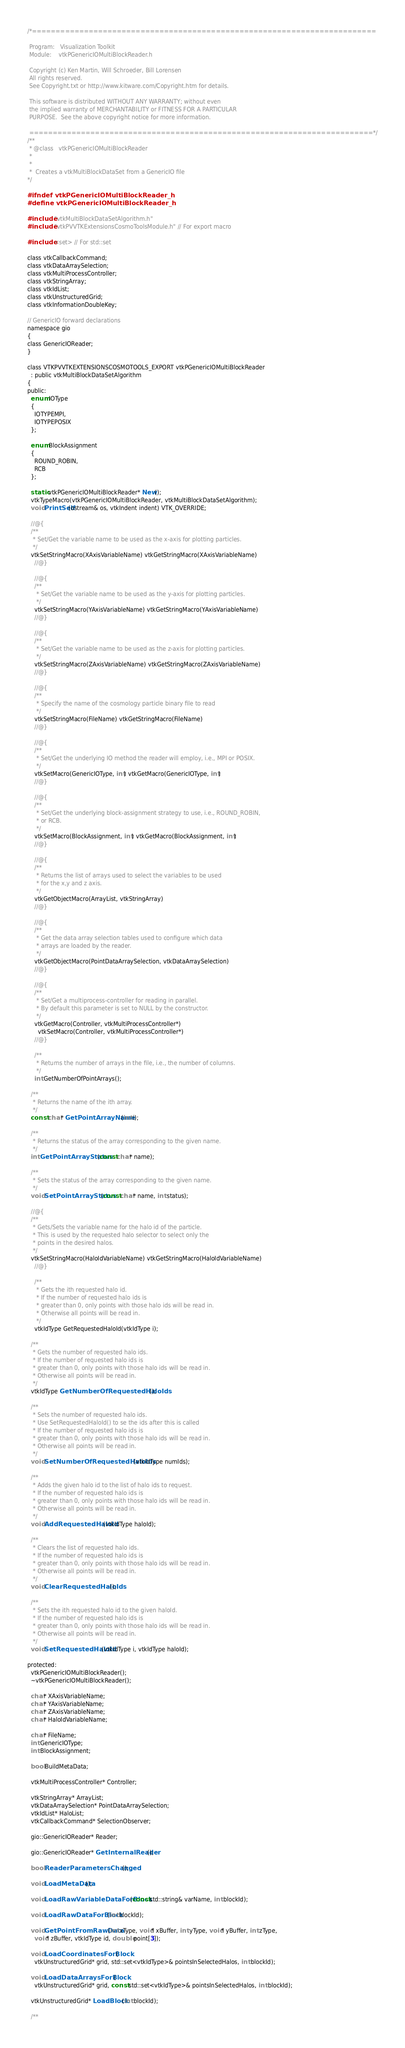Convert code to text. <code><loc_0><loc_0><loc_500><loc_500><_C_>/*=========================================================================

 Program:   Visualization Toolkit
 Module:    vtkPGenericIOMultiBlockReader.h

 Copyright (c) Ken Martin, Will Schroeder, Bill Lorensen
 All rights reserved.
 See Copyright.txt or http://www.kitware.com/Copyright.htm for details.

 This software is distributed WITHOUT ANY WARRANTY; without even
 the implied warranty of MERCHANTABILITY or FITNESS FOR A PARTICULAR
 PURPOSE.  See the above copyright notice for more information.

 =========================================================================*/
/**
 * @class   vtkPGenericIOMultiBlockReader
 *
 *
 *  Creates a vtkMultiBlockDataSet from a GenericIO file
*/

#ifndef vtkPGenericIOMultiBlockReader_h
#define vtkPGenericIOMultiBlockReader_h

#include "vtkMultiBlockDataSetAlgorithm.h"
#include "vtkPVVTKExtensionsCosmoToolsModule.h" // For export macro

#include <set> // For std::set

class vtkCallbackCommand;
class vtkDataArraySelection;
class vtkMultiProcessController;
class vtkStringArray;
class vtkIdList;
class vtkUnstructuredGrid;
class vtkInformationDoubleKey;

// GenericIO forward declarations
namespace gio
{
class GenericIOReader;
}

class VTKPVVTKEXTENSIONSCOSMOTOOLS_EXPORT vtkPGenericIOMultiBlockReader
  : public vtkMultiBlockDataSetAlgorithm
{
public:
  enum IOType
  {
    IOTYPEMPI,
    IOTYPEPOSIX
  };

  enum BlockAssignment
  {
    ROUND_ROBIN,
    RCB
  };

  static vtkPGenericIOMultiBlockReader* New();
  vtkTypeMacro(vtkPGenericIOMultiBlockReader, vtkMultiBlockDataSetAlgorithm);
  void PrintSelf(ostream& os, vtkIndent indent) VTK_OVERRIDE;

  //@{
  /**
   * Set/Get the variable name to be used as the x-axis for plotting particles.
   */
  vtkSetStringMacro(XAxisVariableName) vtkGetStringMacro(XAxisVariableName)
    //@}

    //@{
    /**
     * Set/Get the variable name to be used as the y-axis for plotting particles.
     */
    vtkSetStringMacro(YAxisVariableName) vtkGetStringMacro(YAxisVariableName)
    //@}

    //@{
    /**
     * Set/Get the variable name to be used as the z-axis for plotting particles.
     */
    vtkSetStringMacro(ZAxisVariableName) vtkGetStringMacro(ZAxisVariableName)
    //@}

    //@{
    /**
     * Specify the name of the cosmology particle binary file to read
     */
    vtkSetStringMacro(FileName) vtkGetStringMacro(FileName)
    //@}

    //@{
    /**
     * Set/Get the underlying IO method the reader will employ, i.e., MPI or POSIX.
     */
    vtkSetMacro(GenericIOType, int) vtkGetMacro(GenericIOType, int)
    //@}

    //@{
    /**
     * Set/Get the underlying block-assignment strategy to use, i.e., ROUND_ROBIN,
     * or RCB.
     */
    vtkSetMacro(BlockAssignment, int) vtkGetMacro(BlockAssignment, int)
    //@}

    //@{
    /**
     * Returns the list of arrays used to select the variables to be used
     * for the x,y and z axis.
     */
    vtkGetObjectMacro(ArrayList, vtkStringArray)
    //@}

    //@{
    /**
     * Get the data array selection tables used to configure which data
     * arrays are loaded by the reader.
     */
    vtkGetObjectMacro(PointDataArraySelection, vtkDataArraySelection)
    //@}

    //@{
    /**
     * Set/Get a multiprocess-controller for reading in parallel.
     * By default this parameter is set to NULL by the constructor.
     */
    vtkGetMacro(Controller, vtkMultiProcessController*)
      vtkSetMacro(Controller, vtkMultiProcessController*)
    //@}

    /**
     * Returns the number of arrays in the file, i.e., the number of columns.
     */
    int GetNumberOfPointArrays();

  /**
   * Returns the name of the ith array.
   */
  const char* GetPointArrayName(int i);

  /**
   * Returns the status of the array corresponding to the given name.
   */
  int GetPointArrayStatus(const char* name);

  /**
   * Sets the status of the array corresponding to the given name.
   */
  void SetPointArrayStatus(const char* name, int status);

  //@{
  /**
   * Gets/Sets the variable name for the halo id of the particle.
   * This is used by the requested halo selector to select only the
   * points in the desired halos.
   */
  vtkSetStringMacro(HaloIdVariableName) vtkGetStringMacro(HaloIdVariableName)
    //@}

    /**
     * Gets the ith requested halo id.
     * If the number of requested halo ids is
     * greater than 0, only points with those halo ids will be read in.
     * Otherwise all points will be read in.
     */
    vtkIdType GetRequestedHaloId(vtkIdType i);

  /**
   * Gets the number of requested halo ids.
   * If the number of requested halo ids is
   * greater than 0, only points with those halo ids will be read in.
   * Otherwise all points will be read in.
   */
  vtkIdType GetNumberOfRequestedHaloIds();

  /**
   * Sets the number of requested halo ids.
   * Use SetRequestedHaloId() to se the ids after this is called
   * If the number of requested halo ids is
   * greater than 0, only points with those halo ids will be read in.
   * Otherwise all points will be read in.
   */
  void SetNumberOfRequestedHaloIds(vtkIdType numIds);

  /**
   * Adds the given halo id to the list of halo ids to request.
   * If the number of requested halo ids is
   * greater than 0, only points with those halo ids will be read in.
   * Otherwise all points will be read in.
   */
  void AddRequestedHaloId(vtkIdType haloId);

  /**
   * Clears the list of requested halo ids.
   * If the number of requested halo ids is
   * greater than 0, only points with those halo ids will be read in.
   * Otherwise all points will be read in.
   */
  void ClearRequestedHaloIds();

  /**
   * Sets the ith requested halo id to the given haloId.
   * If the number of requested halo ids is
   * greater than 0, only points with those halo ids will be read in.
   * Otherwise all points will be read in.
   */
  void SetRequestedHaloId(vtkIdType i, vtkIdType haloId);

protected:
  vtkPGenericIOMultiBlockReader();
  ~vtkPGenericIOMultiBlockReader();

  char* XAxisVariableName;
  char* YAxisVariableName;
  char* ZAxisVariableName;
  char* HaloIdVariableName;

  char* FileName;
  int GenericIOType;
  int BlockAssignment;

  bool BuildMetaData;

  vtkMultiProcessController* Controller;

  vtkStringArray* ArrayList;
  vtkDataArraySelection* PointDataArraySelection;
  vtkIdList* HaloList;
  vtkCallbackCommand* SelectionObserver;

  gio::GenericIOReader* Reader;

  gio::GenericIOReader* GetInternalReader();

  bool ReaderParametersChanged();

  void LoadMetaData();

  void LoadRawVariableDataForBlock(const std::string& varName, int blockId);

  void LoadRawDataForBlock(int blockId);

  void GetPointFromRawData(int xType, void* xBuffer, int yType, void* yBuffer, int zType,
    void* zBuffer, vtkIdType id, double point[3]);

  void LoadCoordinatesForBlock(
    vtkUnstructuredGrid* grid, std::set<vtkIdType>& pointsInSelectedHalos, int blockId);

  void LoadDataArraysForBlock(
    vtkUnstructuredGrid* grid, const std::set<vtkIdType>& pointsInSelectedHalos, int blockId);

  vtkUnstructuredGrid* LoadBlock(int blockId);

  /**</code> 